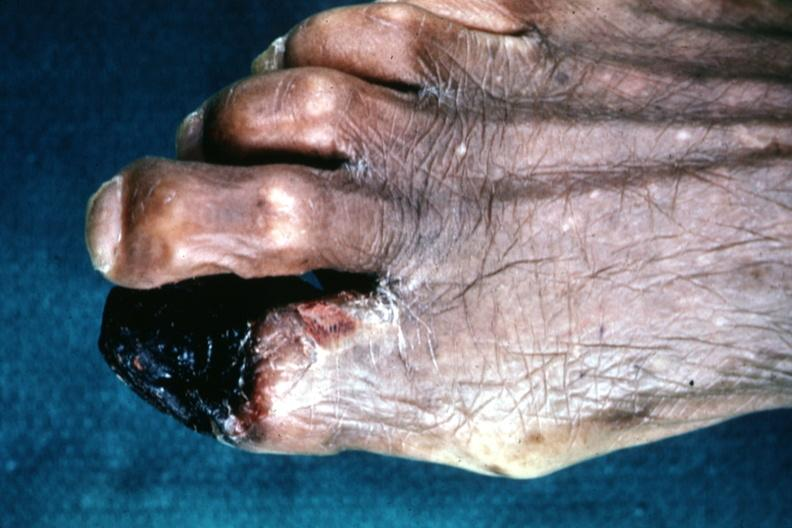does marfans syndrome show excellent great toe lesion?
Answer the question using a single word or phrase. No 